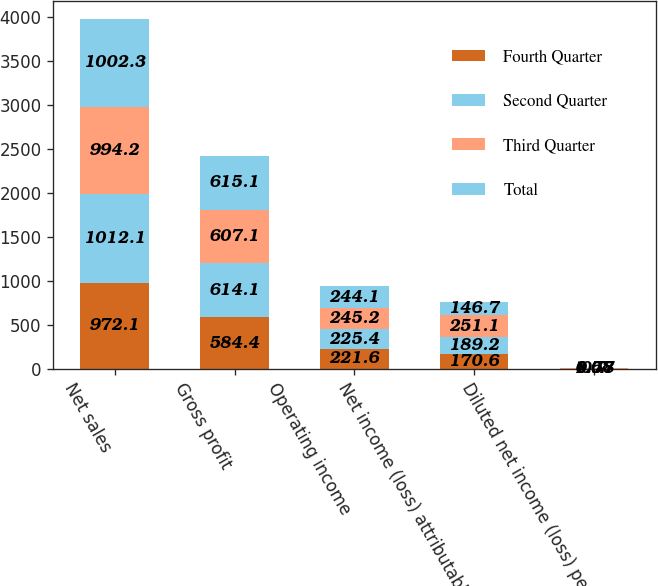Convert chart. <chart><loc_0><loc_0><loc_500><loc_500><stacked_bar_chart><ecel><fcel>Net sales<fcel>Gross profit<fcel>Operating income<fcel>Net income (loss) attributable<fcel>Diluted net income (loss) per<nl><fcel>Fourth Quarter<fcel>972.1<fcel>584.4<fcel>221.6<fcel>170.6<fcel>0.7<nl><fcel>Second Quarter<fcel>1012.1<fcel>614.1<fcel>225.4<fcel>189.2<fcel>0.77<nl><fcel>Third Quarter<fcel>994.2<fcel>607.1<fcel>245.2<fcel>251.1<fcel>1.07<nl><fcel>Total<fcel>1002.3<fcel>615.1<fcel>244.1<fcel>146.7<fcel>0.58<nl></chart> 